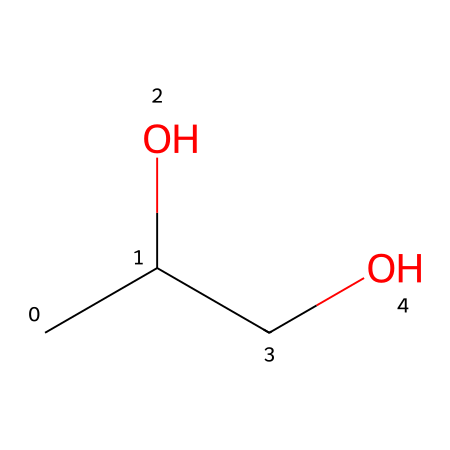What is the molecular formula of propylene glycol? The SMILES notation "CC(O)CO" indicates the presence of two carbon atoms (C), four hydrogen atoms (H), and two oxygen atoms (O). Therefore, the molecular formula can be determined by counting the individual atoms represented in the structure.
Answer: C3H8O2 How many hydroxyl groups are present in this molecule? In the SMILES representation, the "O" is followed by the "C" in "CC(O)CO". This indicates that there are two -OH (hydroxyl) groups present in the molecule.
Answer: 2 What type of chemical is propylene glycol classified as? Given that this molecule contains hydroxyl (-OH) groups and is used in cosmetic products primarily as a moisturizer, it can be classified as a polyol or a glycol.
Answer: polyol What is the significance of the hydroxyl groups in propylene glycol? The hydroxyl groups in propylene glycol are responsible for its ability to retain moisture, making the compound effective as a humectant in cosmetic formulations. This function is central to its role in personal care products.
Answer: moisture retention What is the total number of atoms in propylene glycol? By adding the number of carbon, hydrogen, and oxygen atoms from the molecular formula C3H8O2, we have 3 (C) + 8 (H) + 2 (O) = 13 total atoms.
Answer: 13 